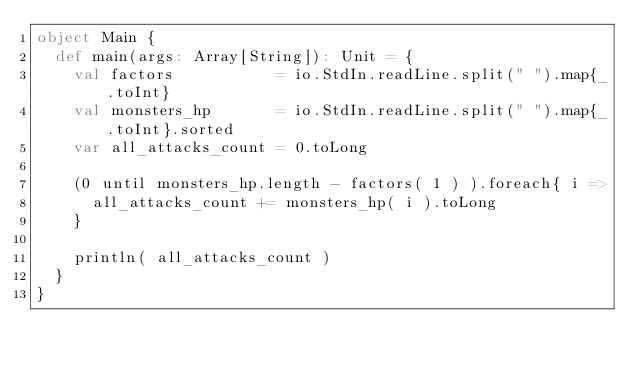Convert code to text. <code><loc_0><loc_0><loc_500><loc_500><_Scala_>object Main {
  def main(args: Array[String]): Unit = {
    val factors           = io.StdIn.readLine.split(" ").map{_.toInt}
    val monsters_hp       = io.StdIn.readLine.split(" ").map{_.toInt}.sorted
    var all_attacks_count = 0.toLong

    (0 until monsters_hp.length - factors( 1 ) ).foreach{ i =>
      all_attacks_count += monsters_hp( i ).toLong
    }

    println( all_attacks_count )
  }
}</code> 